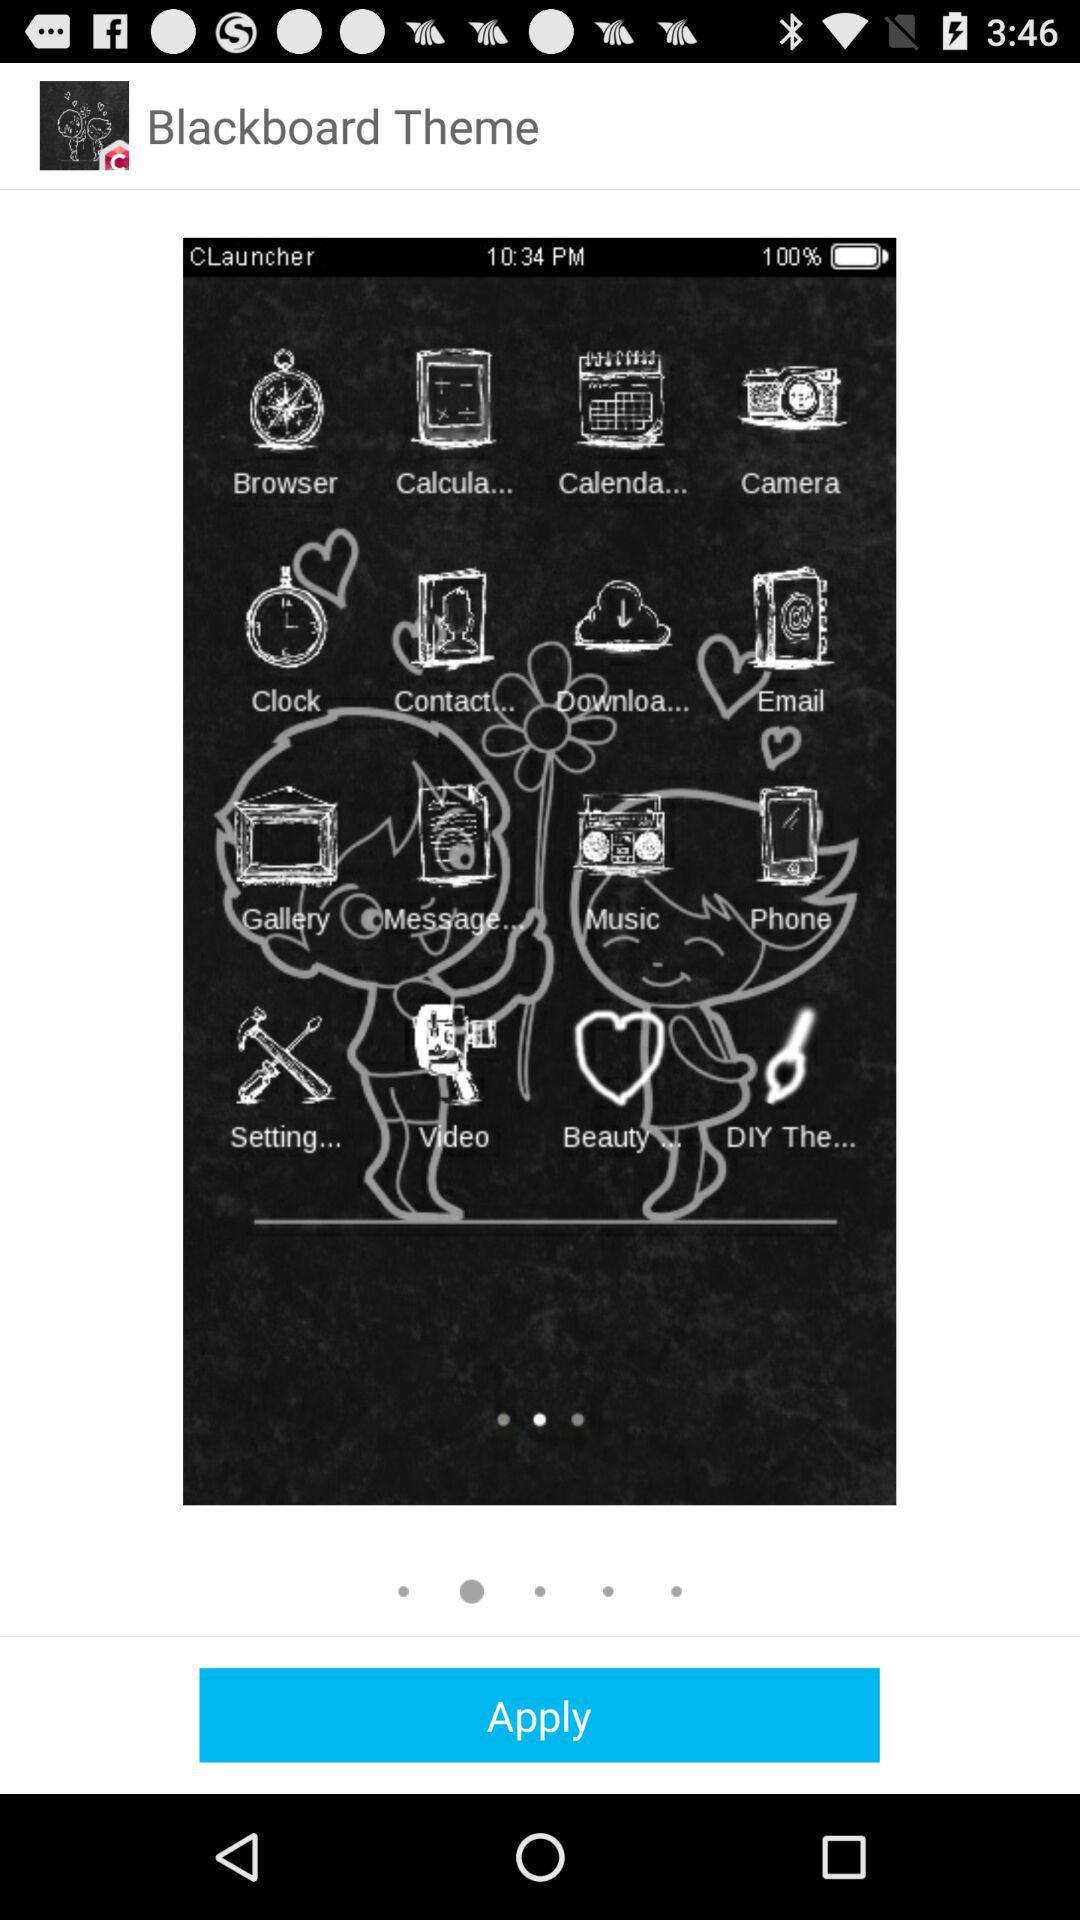How many pager indicators are there on the screen?
Answer the question using a single word or phrase. 2 